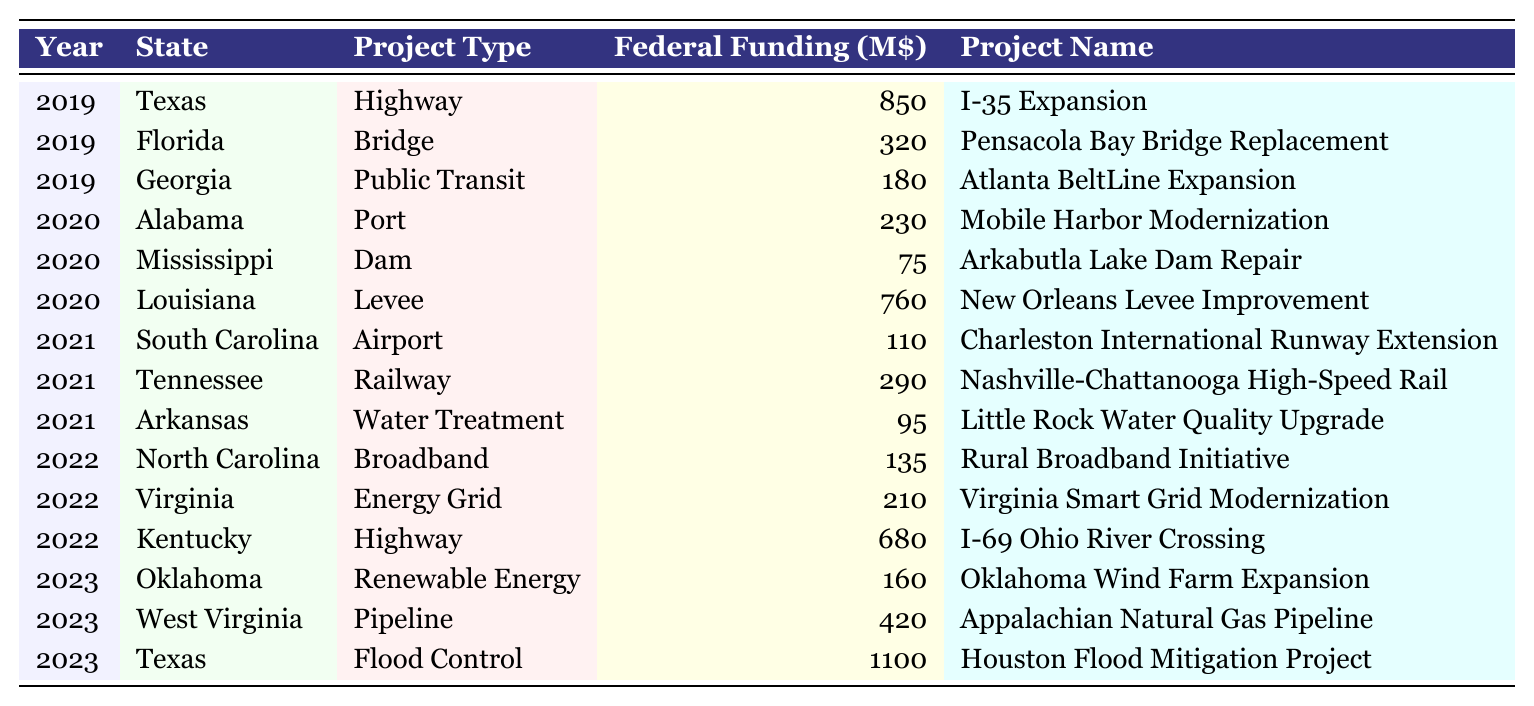What is the total federal funding allocated for projects in Texas over the past 5 years? To find the total federal funding for Texas, we look at each year (2019-2023) and sum the "Federal Funding" values: 850 (2019) + 1100 (2023) = 1950 million. Texas had projects only in 2019 and 2023, so the total funding is 1950 million.
Answer: 1950 million Which state received the highest federal funding in 2020? In 2020, the states received the following funds: Alabama – 230 million, Mississippi – 75 million, Louisiana – 760 million. Louisiana received the highest amount at 760 million.
Answer: Louisiana How many states received federal funding for highway projects? The table indicates the following highway projects: Texas (2019), Kentucky (2022). Thus, 2 states received funding for highway projects.
Answer: 2 states What was the project type that received the least federal funding in 2021? In 2021, we have: South Carolina (Airport - 110 million), Tennessee (Railway - 290 million), Arkansas (Water Treatment - 95 million). Arkansas has the lowest funding of 95 million, which corresponds to a water treatment project.
Answer: Water Treatment Which year had the highest total federal funding awarded among all the states? Calculating total funding per year: 2019 = 850 + 320 + 180 = 1350 million, 2020 = 230 + 75 + 760 = 1065 million, 2021 = 110 + 290 + 95 = 495 million, 2022 = 135 + 210 + 680 = 1025 million, 2023 = 160 + 420 + 1100 = 1680 million. The highest total is in 2023 with 1680 million.
Answer: 2023 Was there any funding allocated for broadband projects in southern states? The table shows that North Carolina received 135 million for a broadband project in 2022, confirming that funding was allocated for broadband projects.
Answer: Yes What is the average federal funding for infrastructure projects across all states in 2022? The total federal funding in 2022: 135 (North Carolina) + 210 (Virginia) + 680 (Kentucky) = 1025 million. There are 3 projects, so the average is 1025/3 = 341.67 million.
Answer: 341.67 million How much more funding was given to flood control projects in Texas compared to bridge projects in Florida? In 2023, Texas received 1100 million for flood control, while Florida received 320 million for a bridge project in 2019. The difference is 1100 - 320 = 780 million.
Answer: 780 million Which project type received the highest total funding over the entire period recorded? Summing federal funding by project type: Highway (850 + 680 = 1530 million), Bridge (320 million), Public Transit (180 million), Port (230 million), Dam (75 million), Levee (760 million), Airport (110 million), Railway (290 million), Water Treatment (95 million), Broadband (135 million), Energy Grid (210 million), Renewable Energy (160 million), Pipeline (420 million). Highway has the highest total at 1530 million.
Answer: Highway In which year was the funding for public transit the highest? The only public transit project in the table is in Georgia (2019) with funding of 180 million. There are no public transit projects in other years, so 2019 has the highest funding for this type.
Answer: 2019 Which state had a project involving dam repair, and what was the allocated federal funding? In 2020, Mississippi had a dam project with an allocated funding of 75 million for the Arkabutla Lake Dam Repair.
Answer: Mississippi; 75 million 